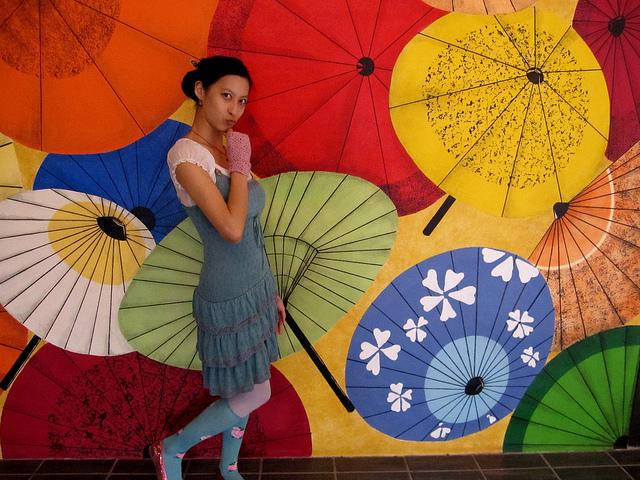What is her name?
Keep it brief. April. How tall is she?
Concise answer only. 5'5". What color glove is the woman wearing?
Quick response, please. Pink. 